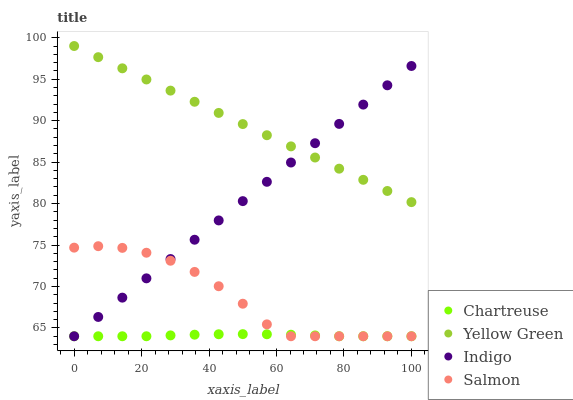Does Chartreuse have the minimum area under the curve?
Answer yes or no. Yes. Does Yellow Green have the maximum area under the curve?
Answer yes or no. Yes. Does Indigo have the minimum area under the curve?
Answer yes or no. No. Does Indigo have the maximum area under the curve?
Answer yes or no. No. Is Yellow Green the smoothest?
Answer yes or no. Yes. Is Salmon the roughest?
Answer yes or no. Yes. Is Chartreuse the smoothest?
Answer yes or no. No. Is Chartreuse the roughest?
Answer yes or no. No. Does Salmon have the lowest value?
Answer yes or no. Yes. Does Yellow Green have the lowest value?
Answer yes or no. No. Does Yellow Green have the highest value?
Answer yes or no. Yes. Does Indigo have the highest value?
Answer yes or no. No. Is Salmon less than Yellow Green?
Answer yes or no. Yes. Is Yellow Green greater than Salmon?
Answer yes or no. Yes. Does Yellow Green intersect Indigo?
Answer yes or no. Yes. Is Yellow Green less than Indigo?
Answer yes or no. No. Is Yellow Green greater than Indigo?
Answer yes or no. No. Does Salmon intersect Yellow Green?
Answer yes or no. No. 